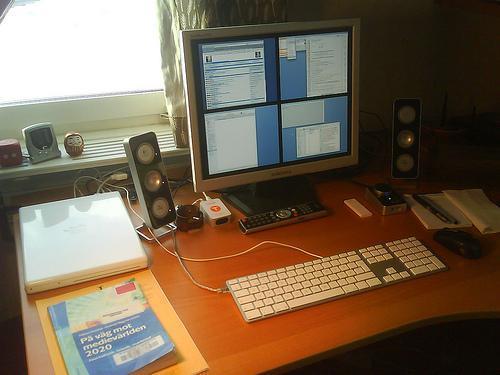How many sections is the display divided into?
Give a very brief answer. 4. How many computer speakers are visible?
Give a very brief answer. 2. How many circular sections are visible on the each computer speaker?
Give a very brief answer. 3. How many cables are connected to the keyboard?
Give a very brief answer. 2. 